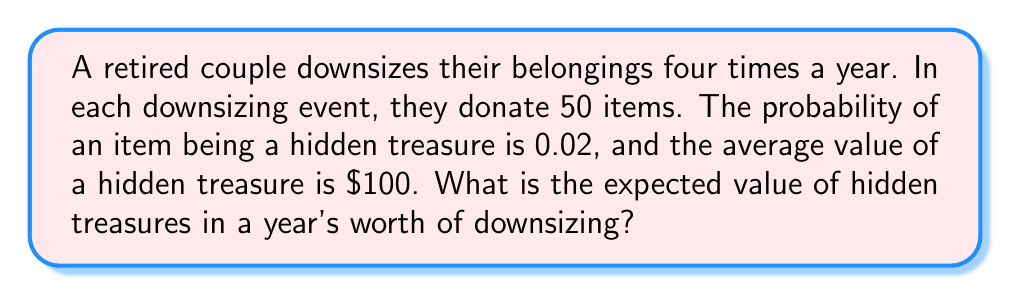Teach me how to tackle this problem. Let's approach this problem step-by-step:

1) First, we need to calculate the number of items donated in a year:
   $$ \text{Items per event} \times \text{Events per year} = 50 \times 4 = 200 \text{ items} $$

2) The probability of an item being a hidden treasure is 0.02, so we can calculate the expected number of hidden treasures in a year:
   $$ \text{Expected treasures} = \text{Total items} \times \text{Probability} = 200 \times 0.02 = 4 \text{ treasures} $$

3) The average value of a hidden treasure is $100. To find the expected value, we multiply the expected number of treasures by the average value:
   $$ \text{Expected value} = \text{Expected treasures} \times \text{Average value} $$
   $$ = 4 \times \$100 = \$400 $$

Therefore, the expected value of hidden treasures in a year's worth of downsizing is $400.
Answer: $400 